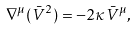<formula> <loc_0><loc_0><loc_500><loc_500>\nabla ^ { \mu } ( \bar { V } ^ { 2 } ) = - 2 \kappa \bar { V } ^ { \mu } ,</formula> 